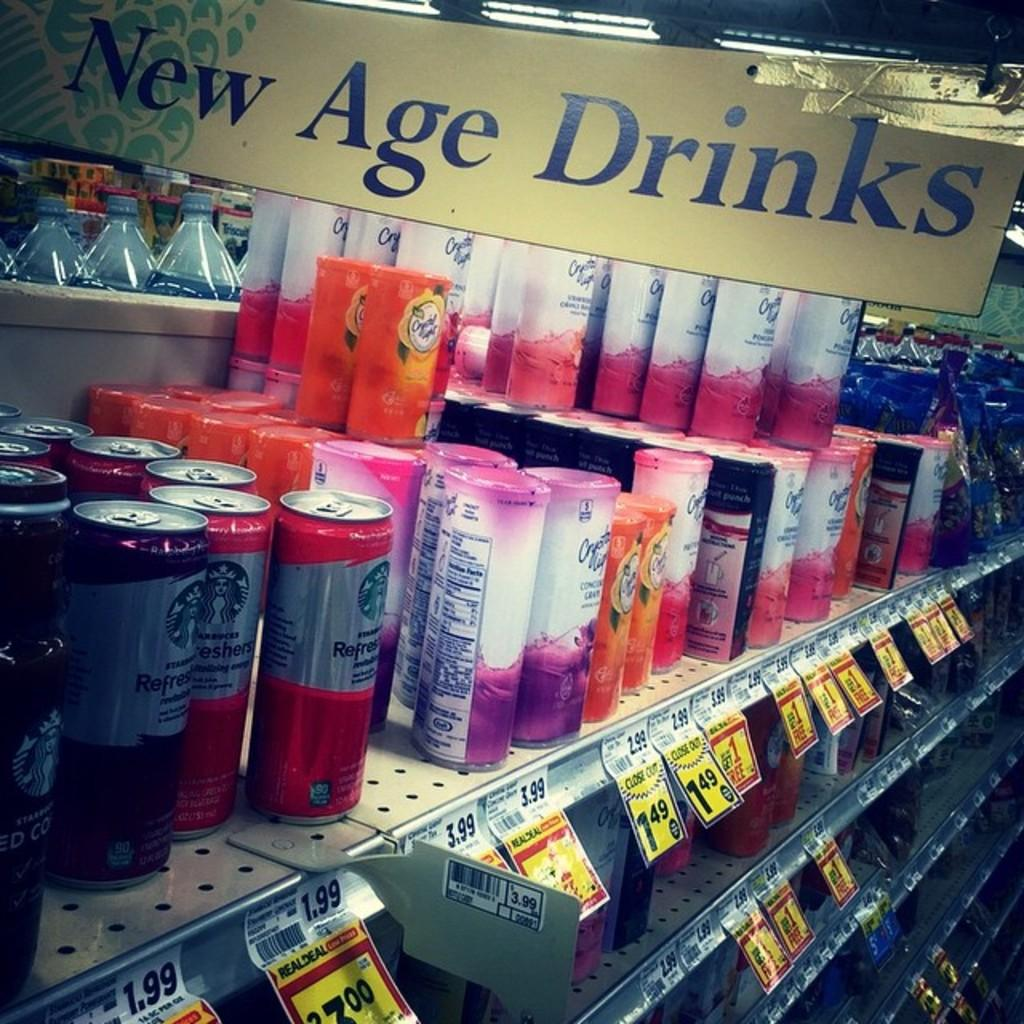<image>
Create a compact narrative representing the image presented. A sign for New Age Drinks is above a drink display in a store. 